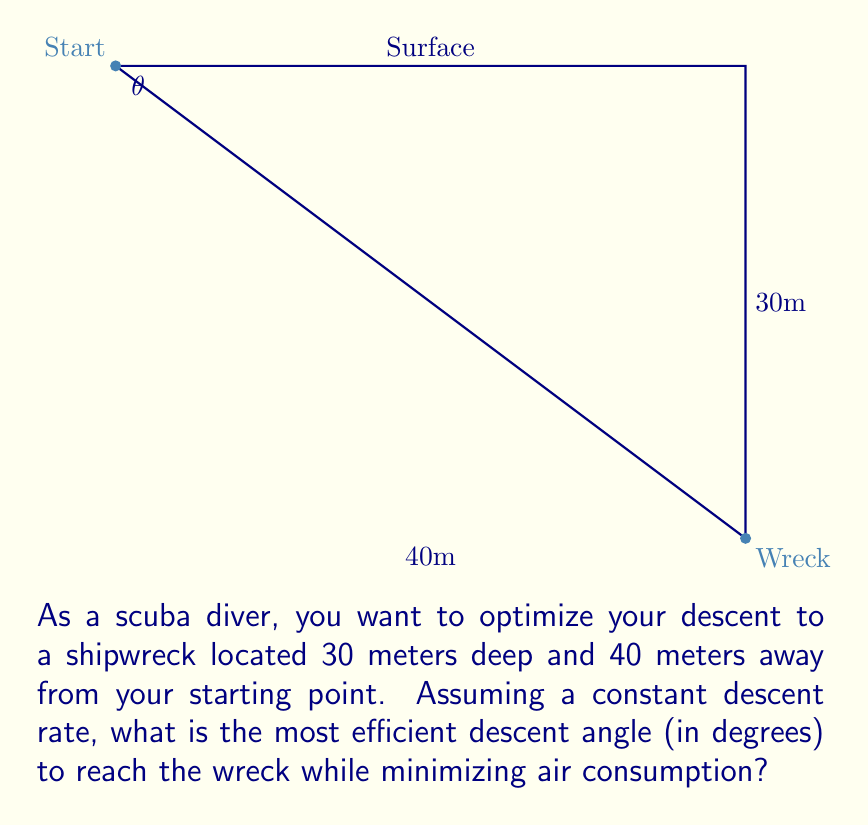Give your solution to this math problem. To find the most efficient descent angle, we need to minimize the distance traveled. The shortest path between two points is a straight line, so we'll calculate the angle of the direct line from the starting point to the wreck.

Let's approach this step-by-step:

1) We can treat this as a right triangle problem, where:
   - The adjacent side is the horizontal distance (40m)
   - The opposite side is the depth (30m)
   - The hypotenuse is the direct line from start to wreck

2) To find the angle, we can use the arctangent function:

   $$\theta = \arctan(\frac{\text{opposite}}{\text{adjacent}})$$

3) Plugging in our values:

   $$\theta = \arctan(\frac{30}{40})$$

4) Simplify the fraction:

   $$\theta = \arctan(\frac{3}{4})$$

5) Calculate the arctangent:

   $$\theta \approx 0.6435 \text{ radians}$$

6) Convert to degrees:

   $$\theta \approx 0.6435 \times \frac{180}{\pi} \approx 36.87°$$

Therefore, the most efficient descent angle is approximately 36.87 degrees.
Answer: 36.87° 